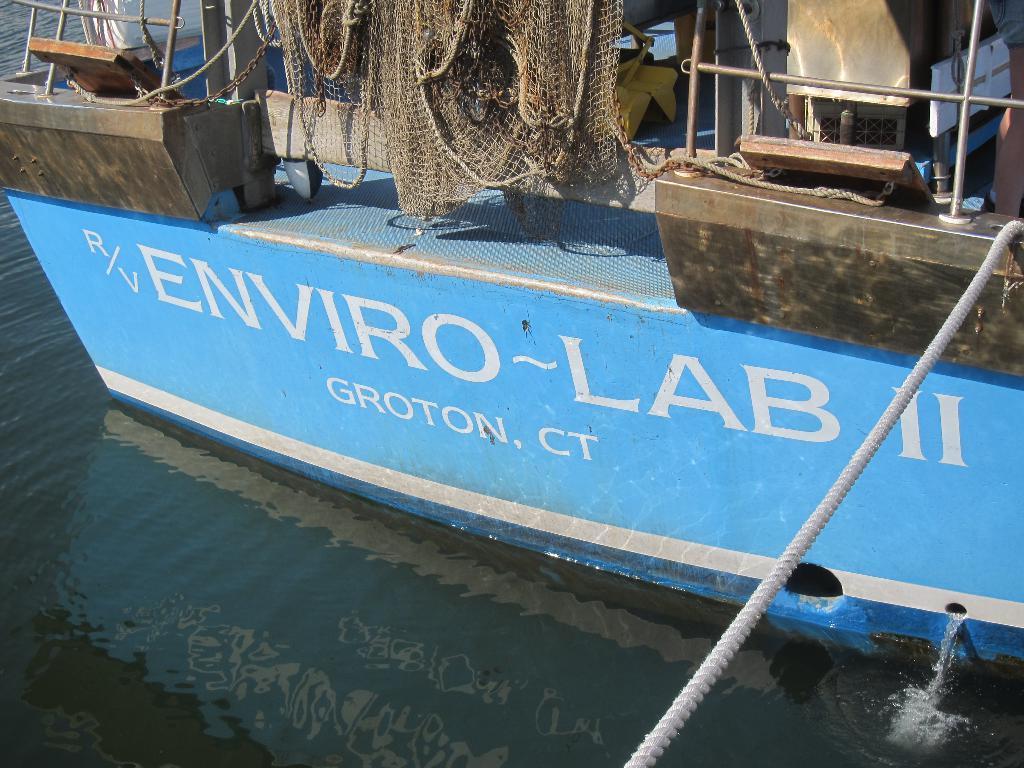Could you give a brief overview of what you see in this image? In this image at the bottom there is a sea, and in the foreground there is a ship and in a ship there is a net, ropes, poles and chains. And on the right side of the image there is a rope. 